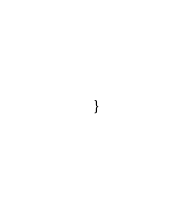Convert code to text. <code><loc_0><loc_0><loc_500><loc_500><_Rust_>}
</code> 